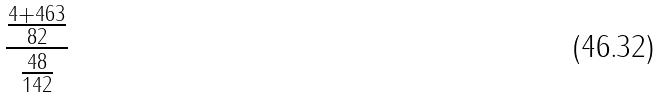Convert formula to latex. <formula><loc_0><loc_0><loc_500><loc_500>\frac { \frac { 4 + 4 6 3 } { 8 2 } } { \frac { 4 8 } { 1 4 2 } }</formula> 